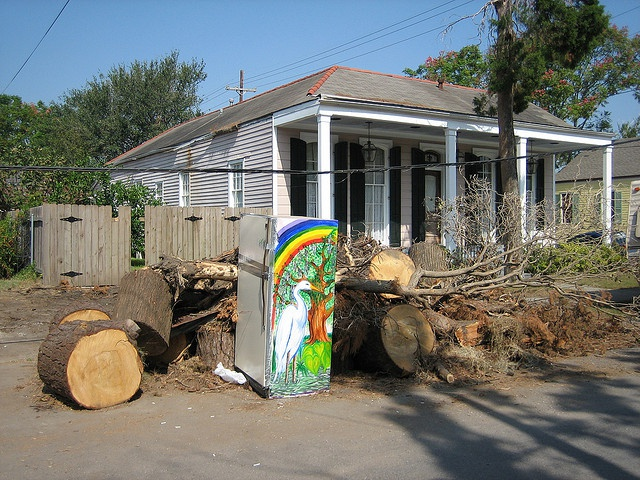Describe the objects in this image and their specific colors. I can see a refrigerator in gray, darkgray, white, and lightgreen tones in this image. 